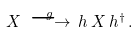Convert formula to latex. <formula><loc_0><loc_0><loc_500><loc_500>X \, \stackrel { g } { \longrightarrow } \, h \, X \, h ^ { \dagger } \, .</formula> 